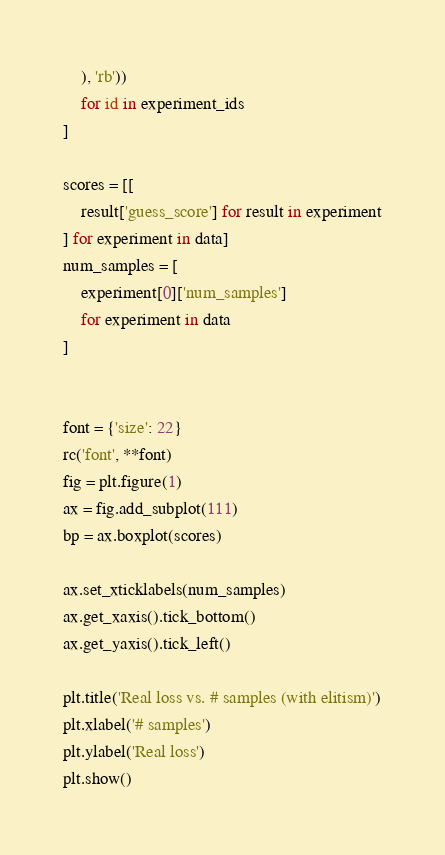Convert code to text. <code><loc_0><loc_0><loc_500><loc_500><_Python_>    ), 'rb'))
    for id in experiment_ids
]

scores = [[
    result['guess_score'] for result in experiment
] for experiment in data]
num_samples = [
    experiment[0]['num_samples']
    for experiment in data
]


font = {'size': 22}
rc('font', **font)
fig = plt.figure(1)
ax = fig.add_subplot(111)
bp = ax.boxplot(scores)

ax.set_xticklabels(num_samples)
ax.get_xaxis().tick_bottom()
ax.get_yaxis().tick_left()

plt.title('Real loss vs. # samples (with elitism)')
plt.xlabel('# samples')
plt.ylabel('Real loss')
plt.show()
</code> 